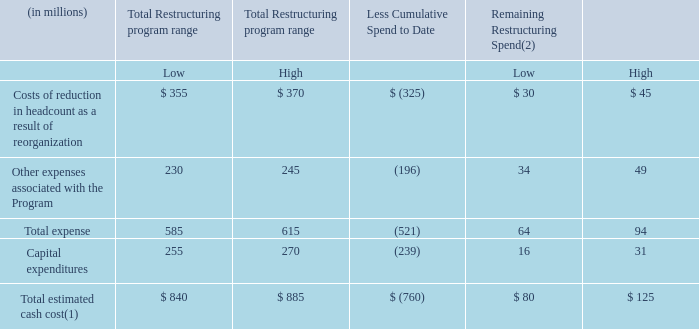Note 12 Restructuring Activities
For the year ended December 31, 2019, the Company incurred $41.9 million of restructuring charges and $60.3 million of other related costs for our restructuring program. These charges were primarily a result of restructuring and associated costs in connection with the Company’s Reinvent SEE strategy.
Our restructuring program (“Program”) is defined as the initiatives associated with our Reinvent SEE strategy in addition to the conclusion of our previously existing restructuring programs at the time of Reinvent SEE's approval. Reinvent SEE is a three-year program approved by the Board of Directors in December 2018. The expected spend in the previously existing program at the time of Reinvent SEE's approval was primarily related to elimination of stranded costs following the sale of Diversey. The Company expects restructuring activities to be completed by the end of 2021.
The Board of Directors has approved cumulative restructuring spend of $840 to $885 million for the Program. Restructuring spend is estimated to be incurred as follows:
(1) Total estimated cash cost excludes the impact of proceeds expected from the sale of property and equipment and foreign currency impact.
(2) Remaining restructuring spend primarily consists of restructuring costs associated with the Company’s Reinvent SEE strategy.
Additionally, the Company anticipates approximately $6.0 million restructuring spend related to recent acquisitions, of which $2.3 million was incurred as of December 31, 2019. The Company expects the remainder of the anticipated spend to be incurred in 2020. See Note 5, "Discontinued Operations, Divestitures and Acquisitions," to the Notes to Consolidated Financial Statements for additional information related to our acquisitions.
How much restructuring charges and other related costs for the restructuring program was incurred for the year ended December 31, 2019 respectively? $41.9 million, $60.3 million. What is the High Total estimated cash cost of Total Restructuring program range?
Answer scale should be: million. $ 885. Who approved the restructuring spend of $840 to $885 million?  The board of directors. Excluding the restructuring spend related to recent acquisitions, what is the low Total estimated cash cost?
Answer scale should be: million. 840-2.3
Answer: 837.7. What is the Total expense expressed as a percentage of Total estimated cash cost for the low estimate?
Answer scale should be: percent. 585/840
Answer: 69.64. For High Total Restructuring program range, what is the Total Capital expenditure expressed as a percentage of total estimated cash cost?
Answer scale should be: percent. 270/885
Answer: 30.51. 